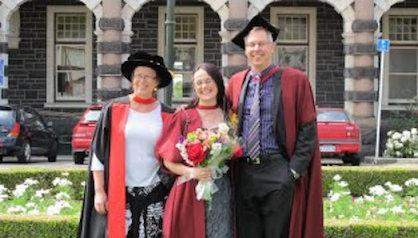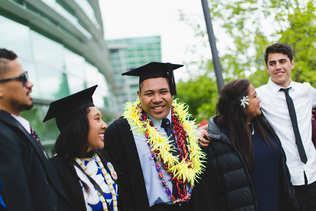The first image is the image on the left, the second image is the image on the right. For the images displayed, is the sentence "There is a graduate with a flower necklace." factually correct? Answer yes or no. Yes. The first image is the image on the left, the second image is the image on the right. Analyze the images presented: Is the assertion "There are 3 people in one of the photos." valid? Answer yes or no. Yes. 